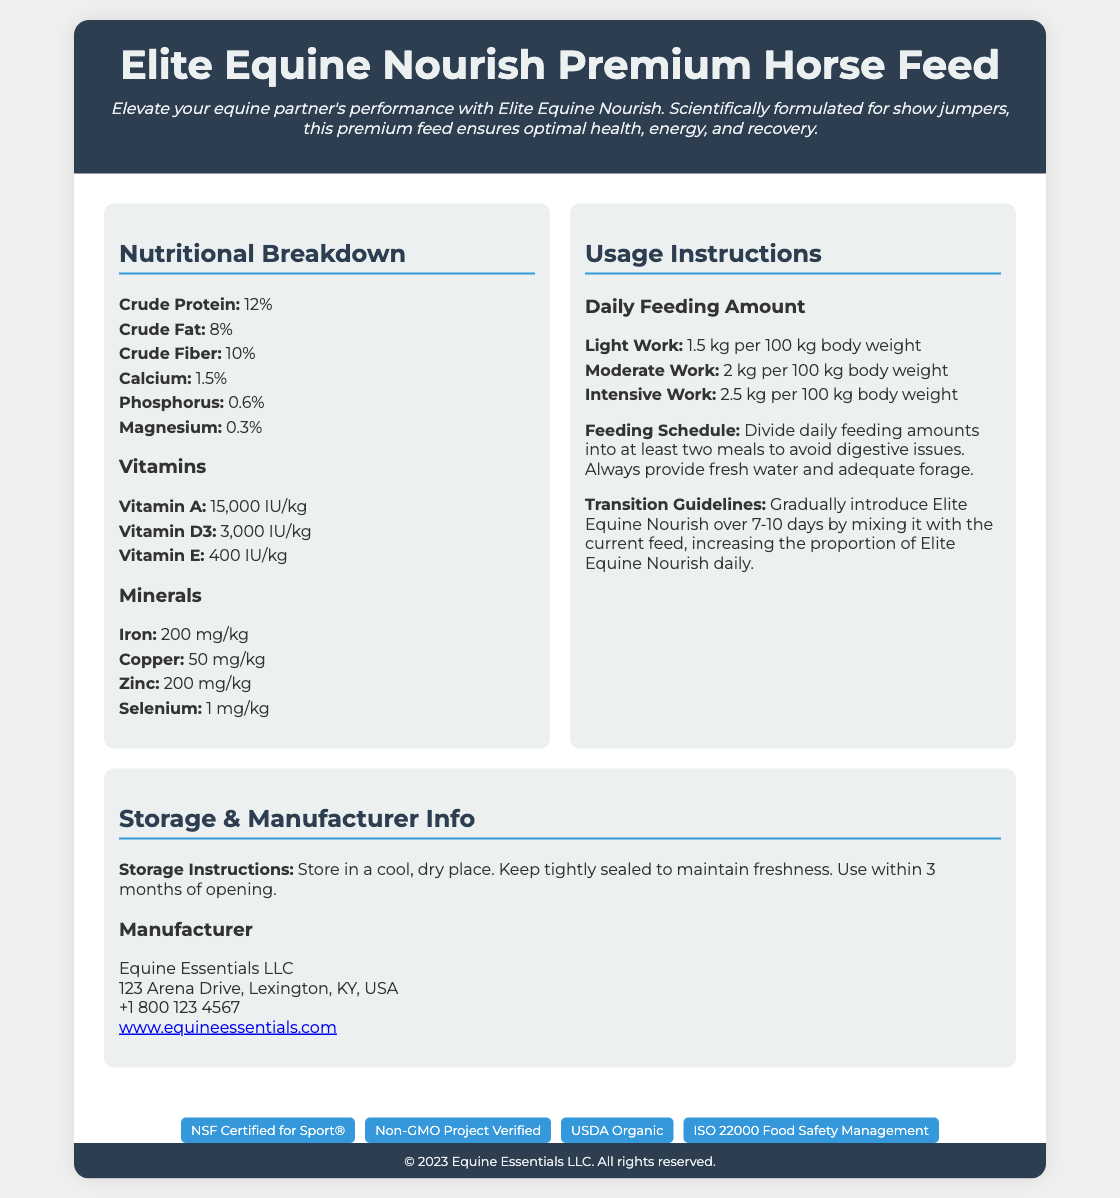What is the crude protein percentage? The crude protein percentage is specifically mentioned in the nutritional breakdown section of the document.
Answer: 12% What is the recommended feeding amount for moderate work? The recommended feeding amount for moderate work is detailed under usage instructions.
Answer: 2 kg per 100 kg body weight What is the storage instruction for the feed? The storage instructions are clearly outlined in the storage & manufacturer info section.
Answer: Store in a cool, dry place Who is the manufacturer of the product? The manufacturer's information is provided in the storage & manufacturer info section.
Answer: Equine Essentials LLC What is the vitamin E content per kg? The vitamin E content is specified in the nutritional breakdown section.
Answer: 400 IU/kg How many certifications does the product have? The certifications are listed at the bottom, indicating how many the product holds.
Answer: Four What is the transition guideline duration? The transition guideline duration is mentioned in the usage instructions.
Answer: 7-10 days What should be included in the feeding schedule? The feeding schedule includes recommendations for meal divisions and additional care details.
Answer: Divide into at least two meals What is the URL for the manufacturer's website? The website link for the manufacturer is provided in the document.
Answer: www.equineessentials.com 